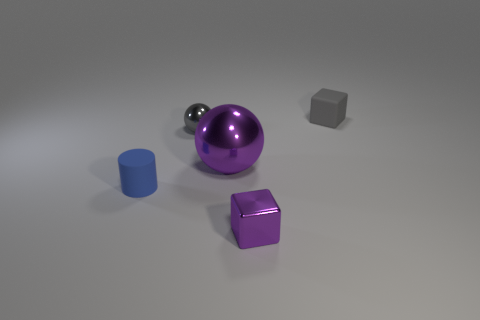Are there an equal number of large purple metal objects that are to the left of the small blue cylinder and metal cubes?
Your response must be concise. No. There is a purple metal cube; are there any blue rubber objects on the left side of it?
Your answer should be very brief. Yes. What size is the purple metallic object to the left of the tiny cube that is on the left side of the cube behind the blue rubber cylinder?
Your response must be concise. Large. Does the object that is on the right side of the tiny purple metallic cube have the same shape as the blue matte thing to the left of the tiny purple shiny thing?
Ensure brevity in your answer.  No. What is the size of the purple object that is the same shape as the small gray matte object?
Offer a very short reply. Small. How many cylinders have the same material as the tiny blue thing?
Offer a very short reply. 0. What material is the gray ball?
Give a very brief answer. Metal. There is a matte thing to the right of the tiny cube that is in front of the matte block; what shape is it?
Give a very brief answer. Cube. What is the shape of the small gray metal object that is on the left side of the large purple sphere?
Your answer should be very brief. Sphere. What number of small objects have the same color as the tiny shiny block?
Ensure brevity in your answer.  0. 